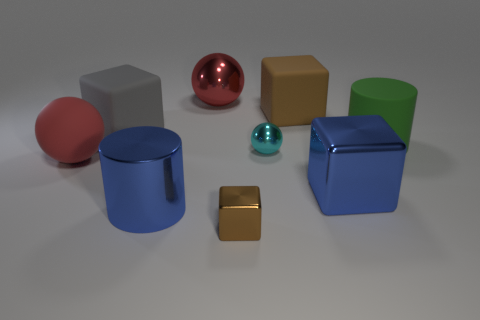The large thing that is both in front of the large rubber ball and to the right of the brown rubber block is what color?
Your response must be concise. Blue. There is a cylinder behind the large matte ball; does it have the same size as the shiny sphere that is in front of the big red metallic thing?
Keep it short and to the point. No. How many large matte things are the same color as the large metal block?
Give a very brief answer. 0. What number of tiny objects are brown matte objects or blue matte cubes?
Keep it short and to the point. 0. Does the brown object behind the big gray matte block have the same material as the tiny ball?
Offer a terse response. No. There is a big sphere that is in front of the small cyan ball; what is its color?
Give a very brief answer. Red. Is there a gray shiny ball of the same size as the gray cube?
Your answer should be compact. No. There is a brown thing that is the same size as the gray object; what is it made of?
Keep it short and to the point. Rubber. Does the brown rubber object have the same size as the metallic cube that is left of the blue cube?
Give a very brief answer. No. What material is the big blue thing that is on the right side of the blue cylinder?
Your response must be concise. Metal. 